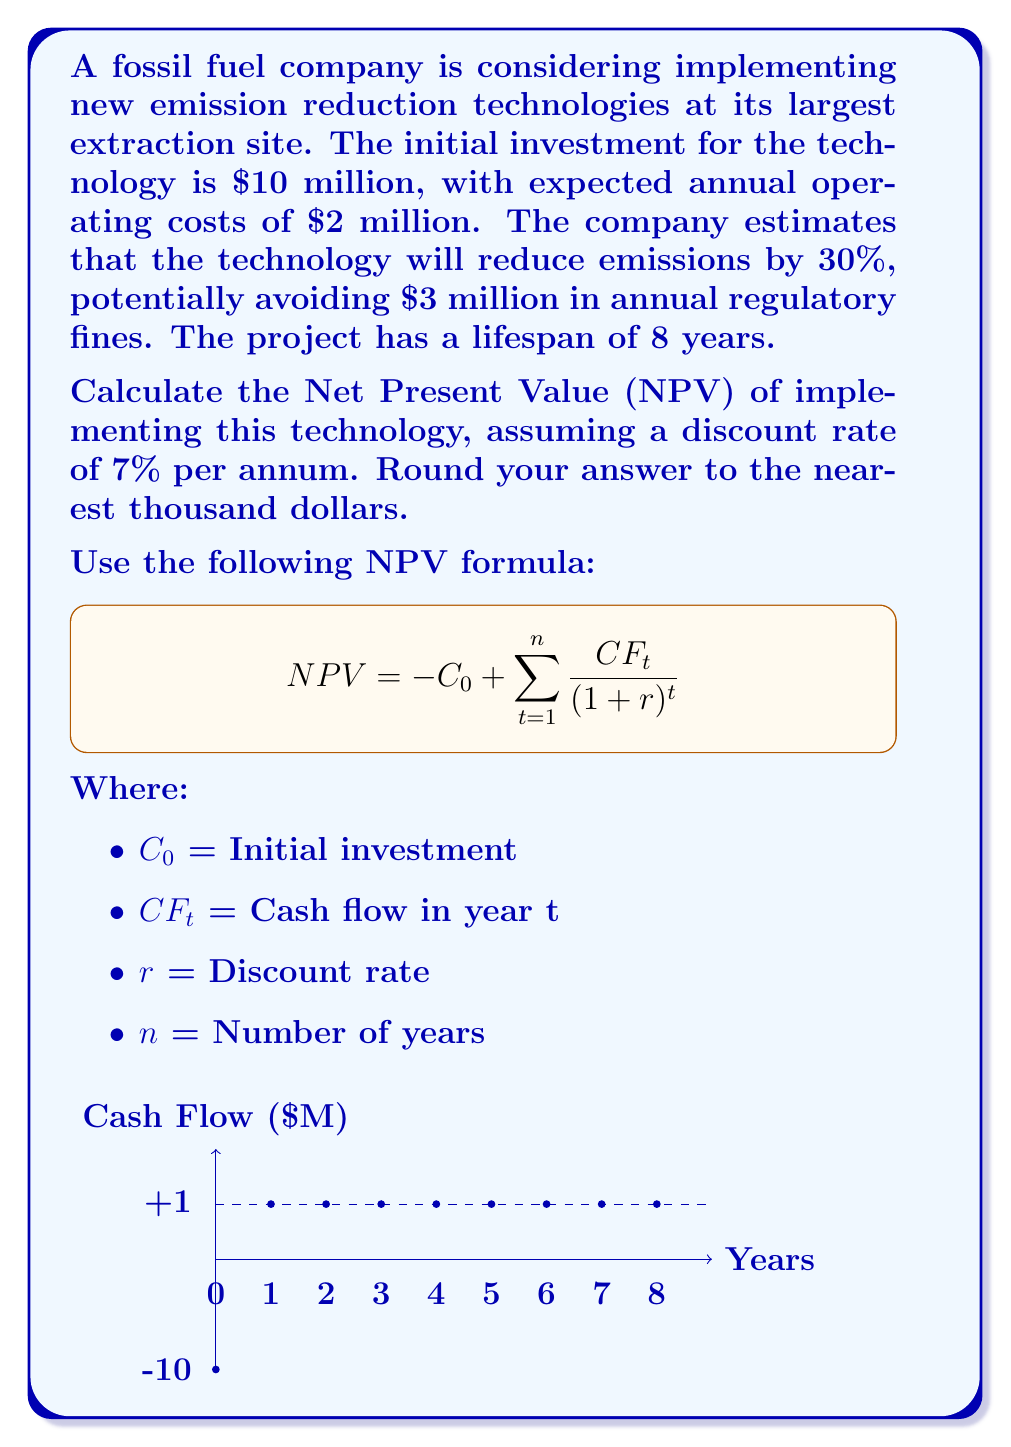Help me with this question. Let's approach this step-by-step:

1) First, let's identify our cash flows:
   - Initial investment ($C_0$) = -$10 million
   - Annual cash flow ($CF_t$) = -$2 million (operating costs) + $3 million (avoided fines) = $1 million

2) We'll use the NPV formula:

   $$ NPV = -C_0 + \sum_{t=1}^{n} \frac{CF_t}{(1+r)^t} $$

   Where:
   $C_0 = 10$ million
   $CF_t = 1$ million (for all t)
   $r = 7\% = 0.07$
   $n = 8$ years

3) Let's calculate the present value of each year's cash flow:

   Year 1: $\frac{1}{(1+0.07)^1} = 0.9346$ million
   Year 2: $\frac{1}{(1+0.07)^2} = 0.8734$ million
   Year 3: $\frac{1}{(1+0.07)^3} = 0.8163$ million
   Year 4: $\frac{1}{(1+0.07)^4} = 0.7629$ million
   Year 5: $\frac{1}{(1+0.07)^5} = 0.7130$ million
   Year 6: $\frac{1}{(1+0.07)^6} = 0.6663$ million
   Year 7: $\frac{1}{(1+0.07)^7} = 0.6227$ million
   Year 8: $\frac{1}{(1+0.07)^8} = 0.5820$ million

4) Sum up all these present values:

   $0.9346 + 0.8734 + 0.8163 + 0.7629 + 0.7130 + 0.6663 + 0.6227 + 0.5820 = 5.9712$ million

5) Now, apply the NPV formula:

   $NPV = -10 + 5.9712 = -4.0288$ million

6) Rounding to the nearest thousand:

   $NPV ≈ -4,029,000$
Answer: $-4,029,000 